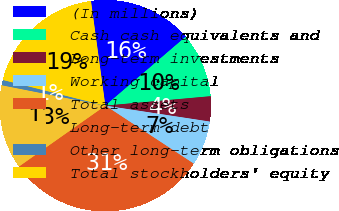Convert chart. <chart><loc_0><loc_0><loc_500><loc_500><pie_chart><fcel>(In millions)<fcel>Cash cash equivalents and<fcel>Long-term investments<fcel>Working capital<fcel>Total assets<fcel>Long-term debt<fcel>Other long-term obligations<fcel>Total stockholders' equity<nl><fcel>15.89%<fcel>9.86%<fcel>3.83%<fcel>6.84%<fcel>30.98%<fcel>12.88%<fcel>0.81%<fcel>18.91%<nl></chart> 